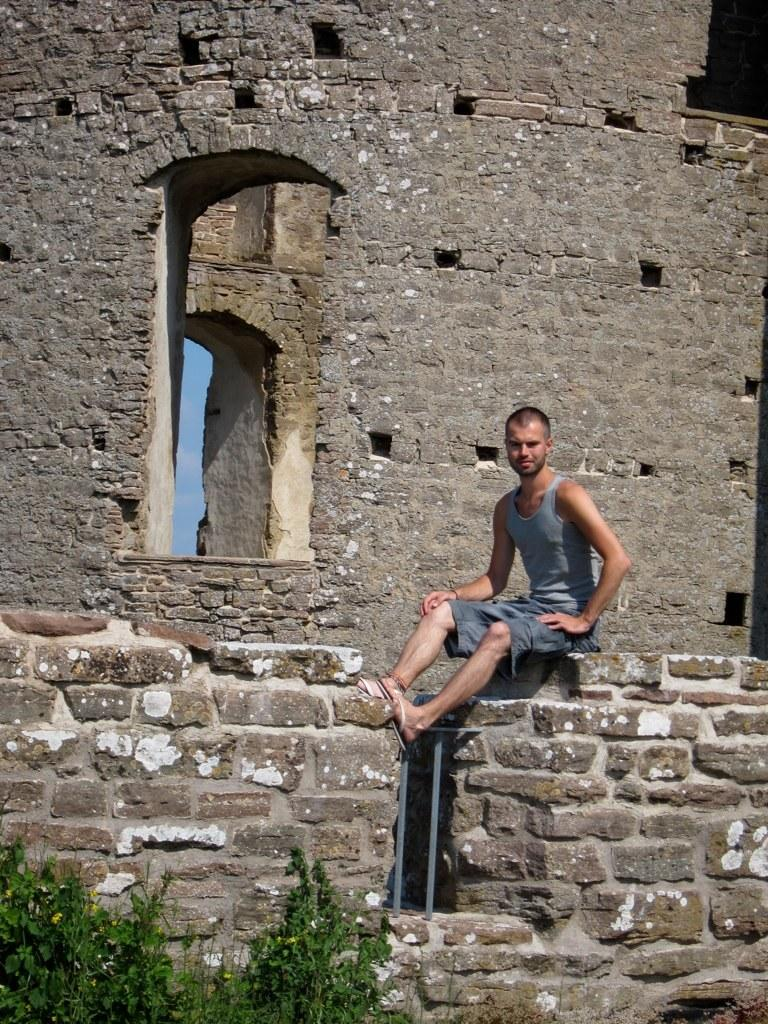Who or what is present in the image? There is a person in the image. What is the person wearing? The person is wearing clothes. What is the person doing in the image? The person is sitting on a wall. What can be seen in the bottom left of the image? There are plants in the bottom left of the image. What architectural feature is visible in the middle of the image? There is a window in the middle of the image. How many houses are visible in the image? There are no houses visible in the image. What level of the building is the person sitting on? The image does not provide information about the level of the building, as it only shows the person sitting on a wall. 